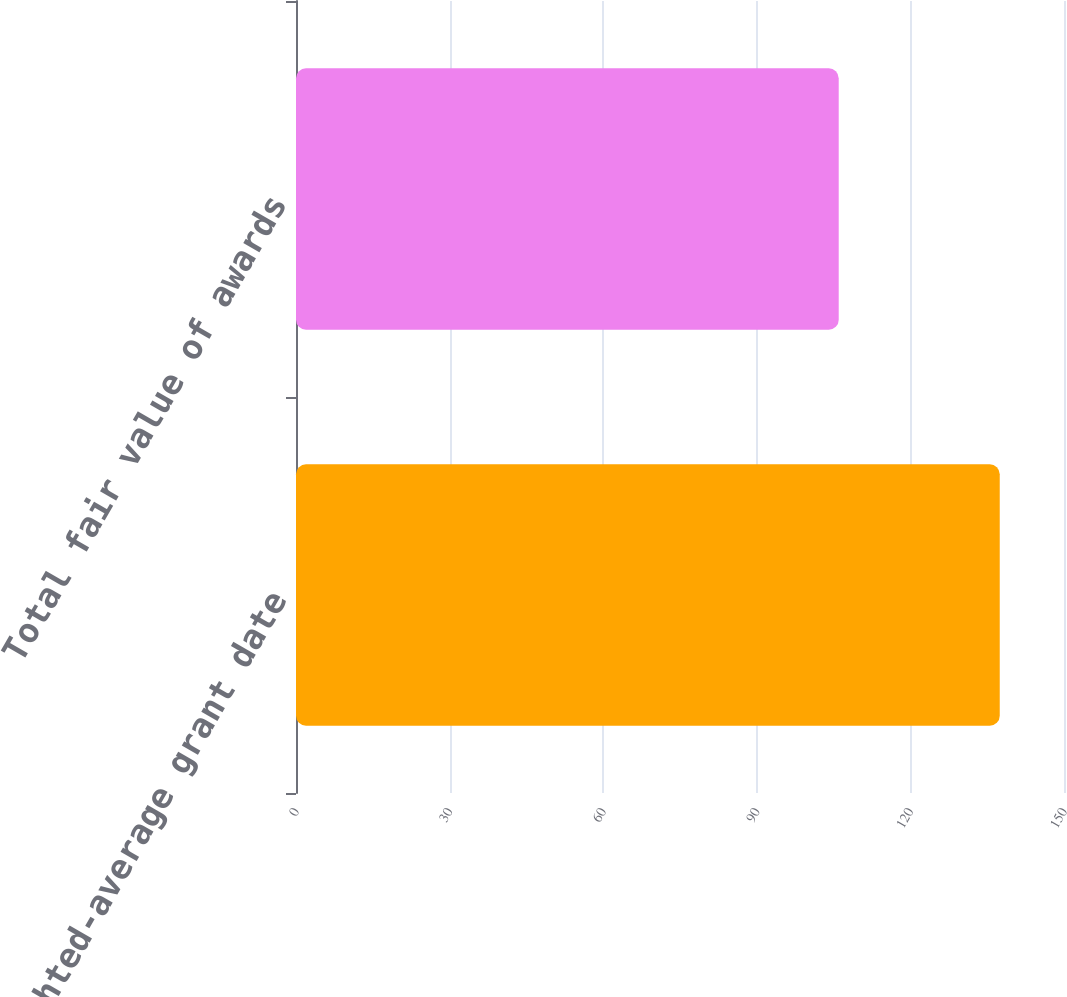<chart> <loc_0><loc_0><loc_500><loc_500><bar_chart><fcel>Weighted-average grant date<fcel>Total fair value of awards<nl><fcel>137.45<fcel>106<nl></chart> 